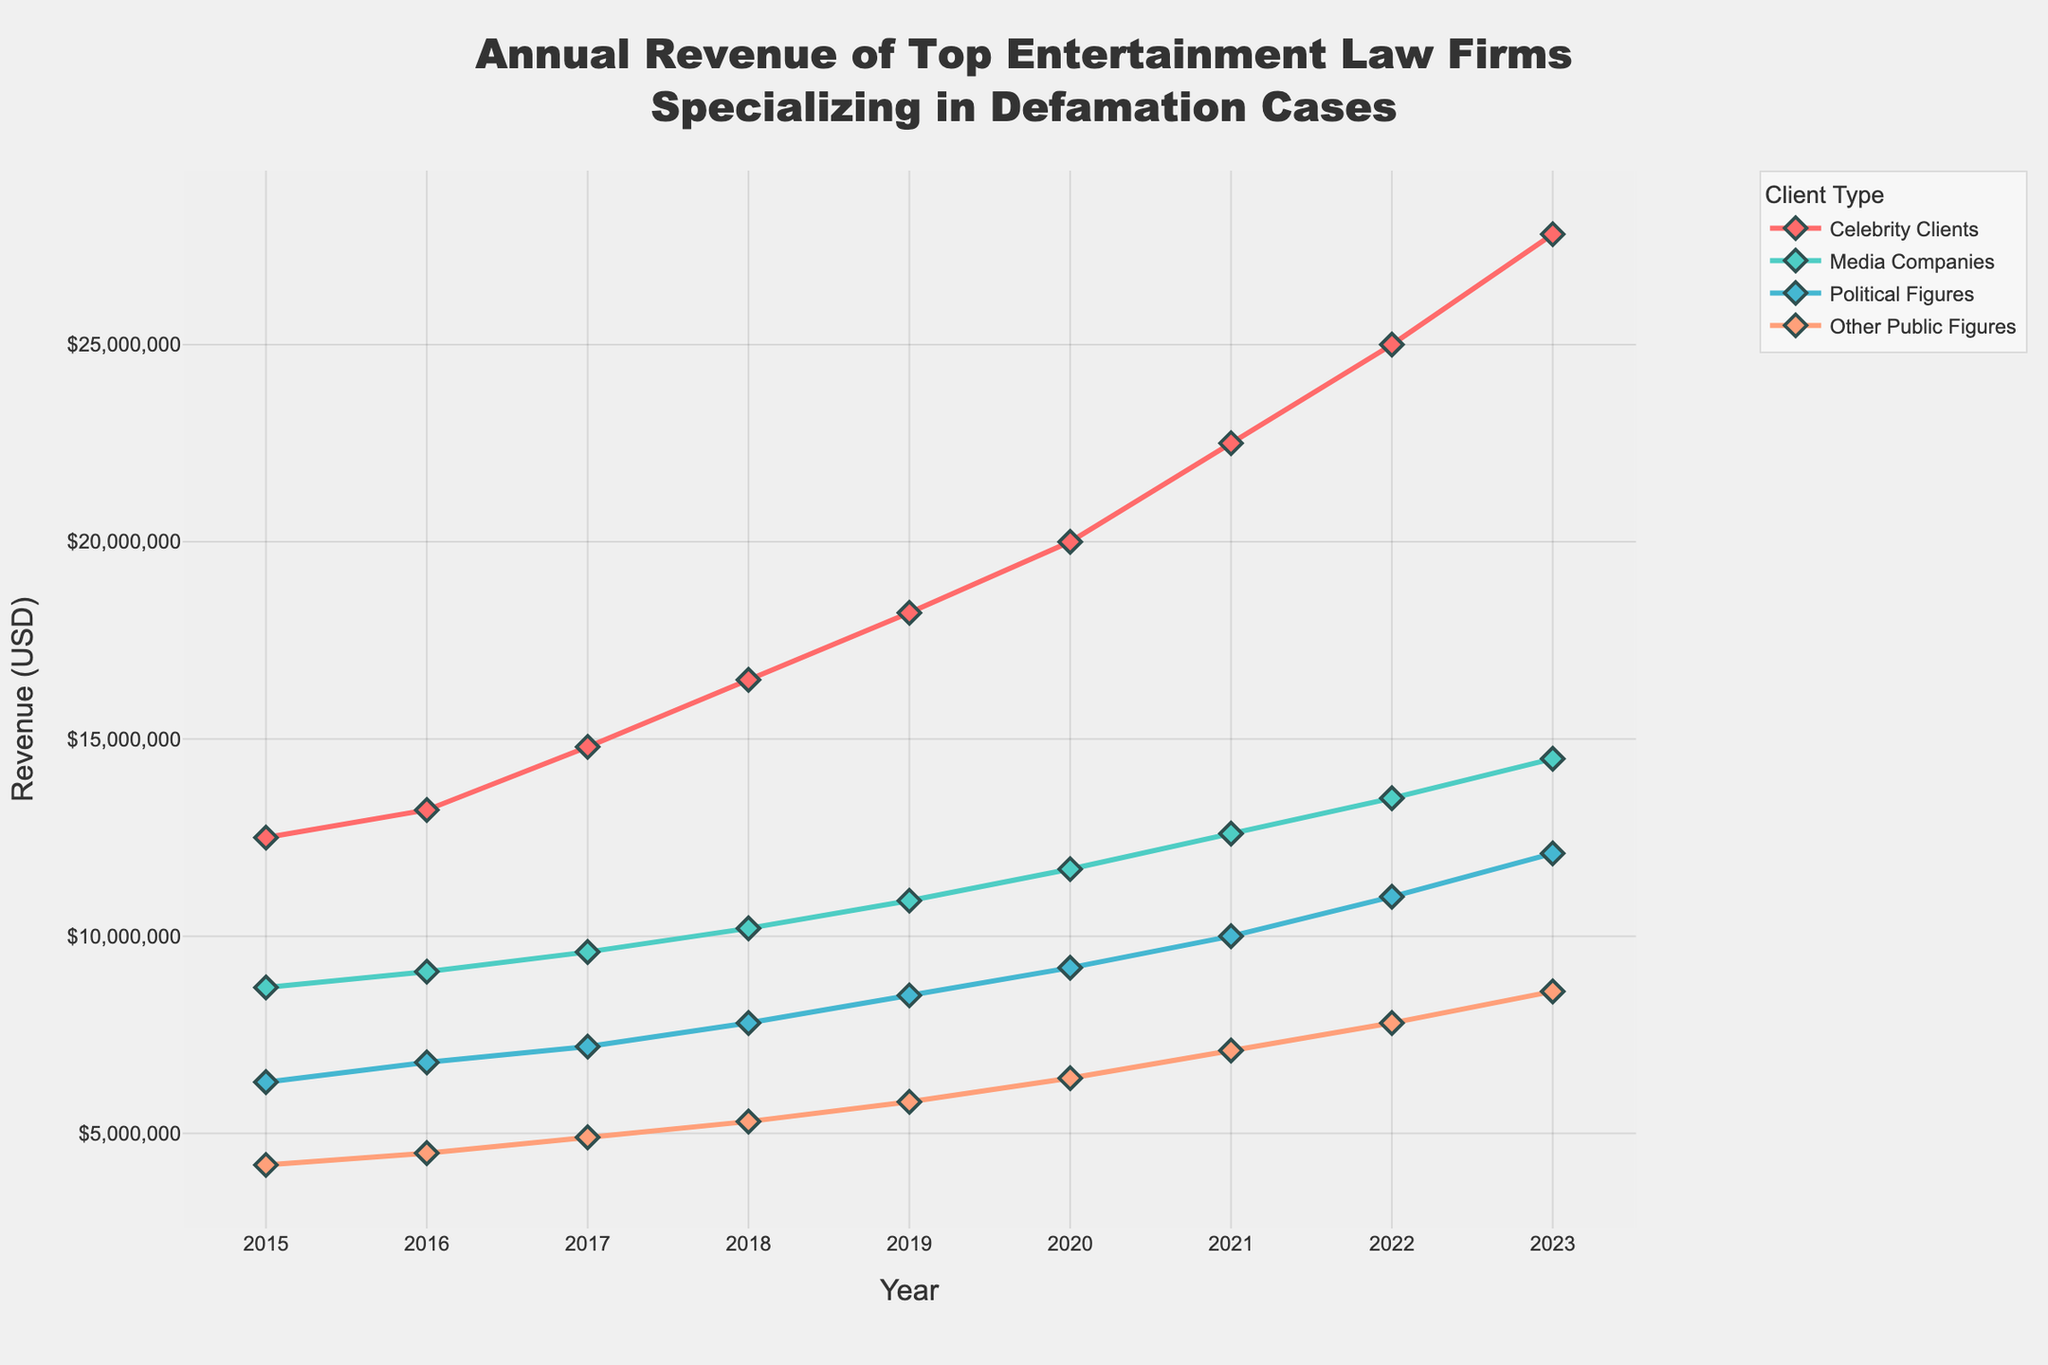What was the total revenue of entertainment law firms from all client types in 2023? To find the total revenue in 2023, sum up the revenue from each client type: 27,800,000 (Celebrity Clients) + 14,500,000 (Media Companies) + 12,100,000 (Political Figures) + 8,600,000 (Other Public Figures) = 63,000,000.
Answer: $63,000,000 Which client type had the highest revenue in 2021? By examining the lines in 2021, Celebrity Clients had the highest revenue at 22,500,000, which is the peak compared to the other client types.
Answer: Celebrity Clients How did the revenue from Media Companies change from 2018 to 2020? To find the change, subtract the 2018 revenue from the 2020 revenue: 11,700,000 (2020) - 10,200,000 (2018) = 1,500,000.
Answer: Increased by $1,500,000 What is the overall trend in revenue for Political Figures from 2015 to 2023? The revenue for Political Figures consistently increased every year from 6,300,000 in 2015 to 12,100,000 in 2023.
Answer: Consistently increasing By how much did the revenue from Celebrity Clients increase from 2015 to 2023? Subtract the revenue in 2015 from the revenue in 2023 for Celebrity Clients: 27,800,000 - 12,500,000 = 15,300,000.
Answer: $15,300,000 Which two client types had the closest revenue figures in 2019, and what was their difference? By comparing the revenue figures in 2019: Other Public Figures had 5,800,000 and Political Figures had 8,500,000. Their difference is: 8,500,000 - 5,800,000 = 2,700,000.
Answer: Other Public Figures and Political Figures, $2,700,000 What client type showed the highest rate of increase in revenue from 2015 to 2023? Calculate the rate of increase for each client type. Celebrity Clients increased from 12,500,000 to 27,800,000. Media Companies increased from 8,700,000 to 14,500,000. Political Figures increased from 6,300,000 to 12,100,000. Other Public Figures increased from 4,200,000 to 8,600,000. The rate of increase for Celebrity Clients is the highest.
Answer: Celebrity Clients In which year did Other Public Figures revenue surpass 7,000,000 for the first time? Check the revenue for Other Public Figures year-wise. The first year it surpasses 7,000,000 is 2021, which shows a revenue of 7,100,000.
Answer: 2021 